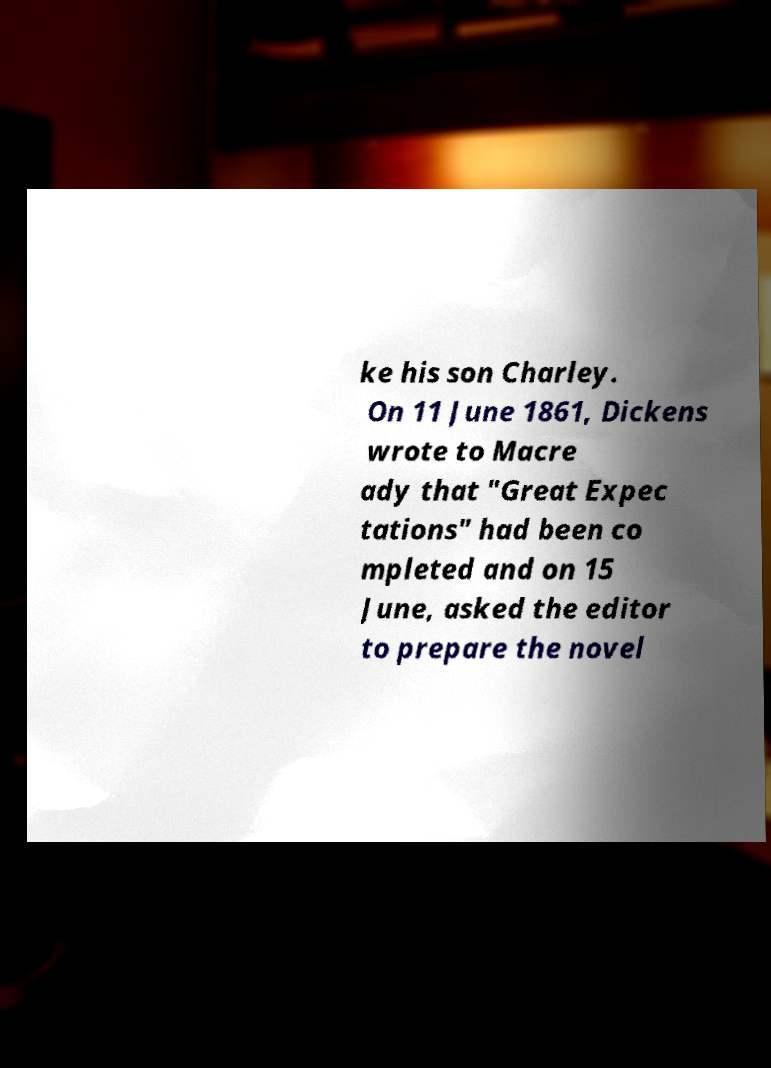Could you assist in decoding the text presented in this image and type it out clearly? ke his son Charley. On 11 June 1861, Dickens wrote to Macre ady that "Great Expec tations" had been co mpleted and on 15 June, asked the editor to prepare the novel 